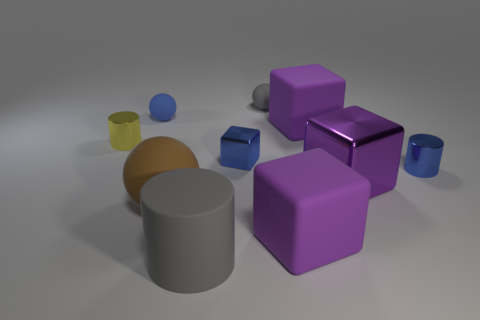Are there more large matte things that are in front of the yellow metallic cylinder than blue spheres in front of the small blue rubber thing?
Your answer should be very brief. Yes. Are there any other things that are the same size as the blue cylinder?
Provide a succinct answer. Yes. How many cylinders are yellow things or purple matte objects?
Your answer should be compact. 1. How many things are either tiny blue shiny things that are on the right side of the purple metal thing or big purple rubber balls?
Your answer should be very brief. 1. What is the shape of the small rubber object on the left side of the brown rubber thing that is in front of the matte ball behind the blue matte object?
Give a very brief answer. Sphere. What number of small green things are the same shape as the blue matte thing?
Give a very brief answer. 0. What is the material of the thing that is the same color as the rubber cylinder?
Keep it short and to the point. Rubber. Does the small blue cylinder have the same material as the tiny gray ball?
Provide a succinct answer. No. What number of large purple blocks are left of the matte ball that is on the right side of the big gray rubber cylinder on the right side of the yellow metallic thing?
Provide a succinct answer. 0. Is there a gray thing that has the same material as the tiny block?
Ensure brevity in your answer.  No. 